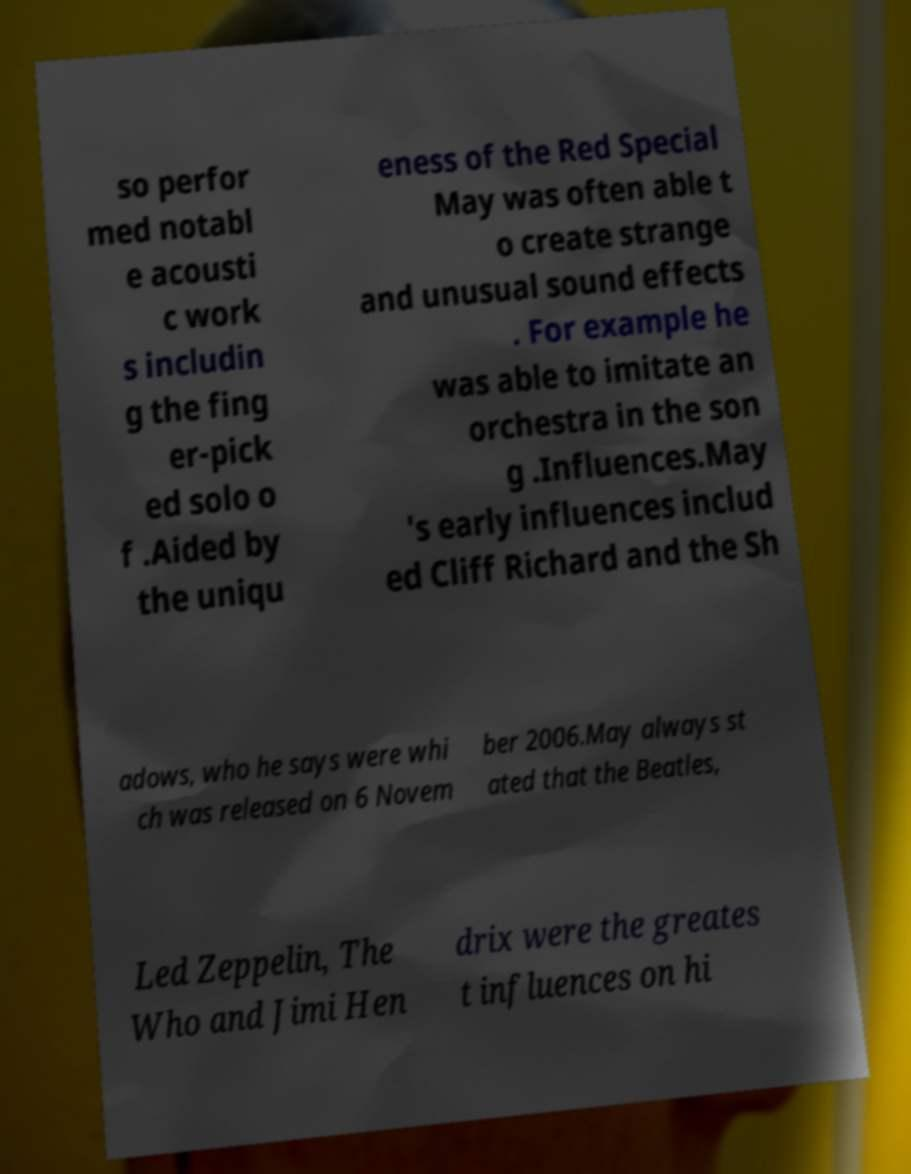What messages or text are displayed in this image? I need them in a readable, typed format. so perfor med notabl e acousti c work s includin g the fing er-pick ed solo o f .Aided by the uniqu eness of the Red Special May was often able t o create strange and unusual sound effects . For example he was able to imitate an orchestra in the son g .Influences.May 's early influences includ ed Cliff Richard and the Sh adows, who he says were whi ch was released on 6 Novem ber 2006.May always st ated that the Beatles, Led Zeppelin, The Who and Jimi Hen drix were the greates t influences on hi 